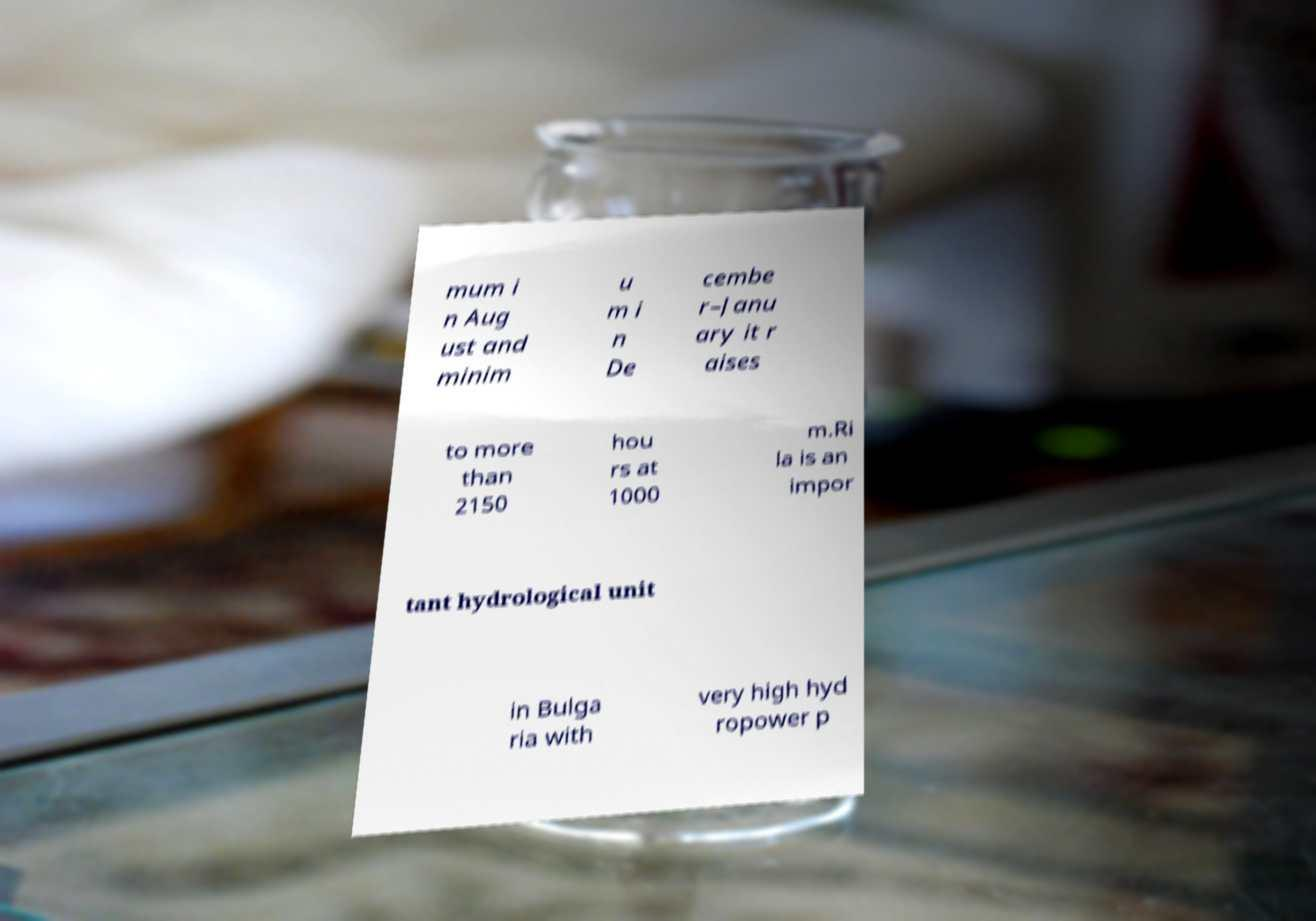I need the written content from this picture converted into text. Can you do that? mum i n Aug ust and minim u m i n De cembe r–Janu ary it r aises to more than 2150 hou rs at 1000 m.Ri la is an impor tant hydrological unit in Bulga ria with very high hyd ropower p 